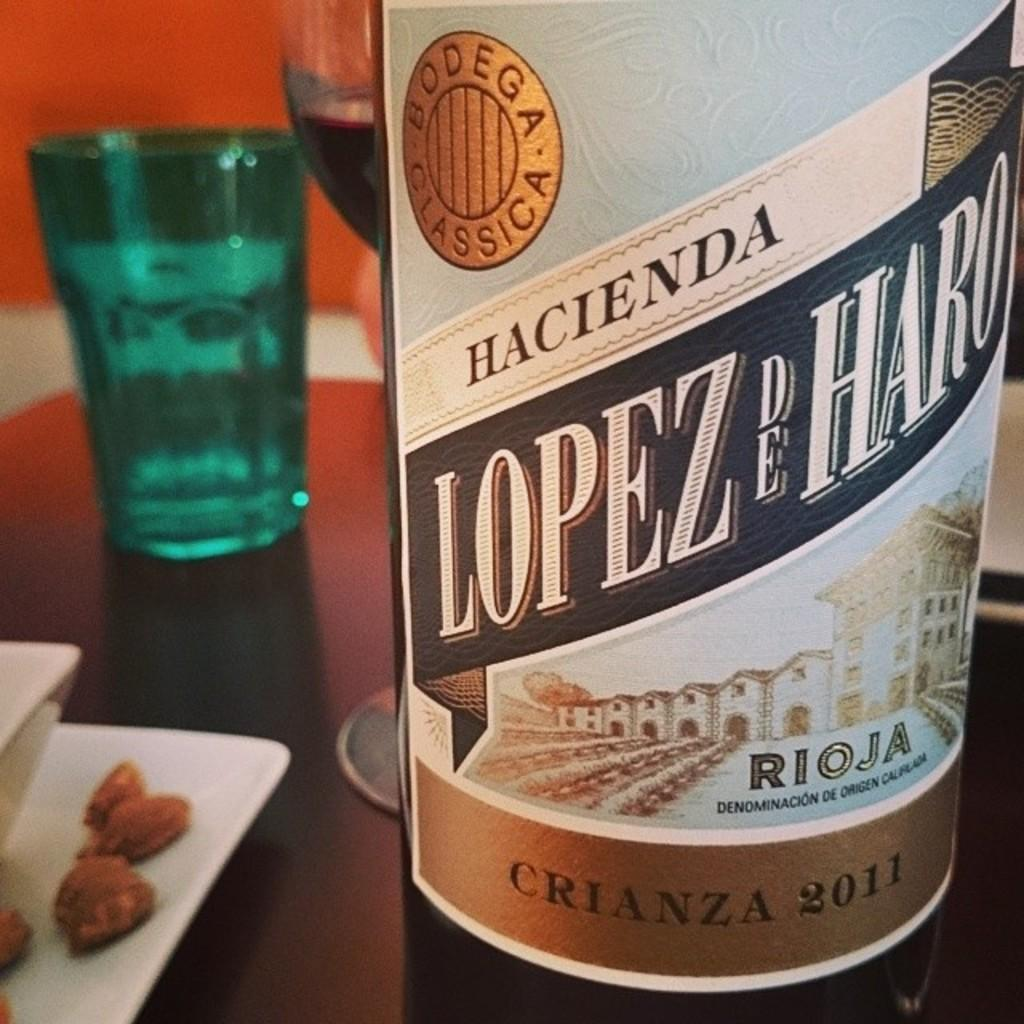<image>
Relay a brief, clear account of the picture shown. a bottle of hacienda lopez de haro crianza 2011 